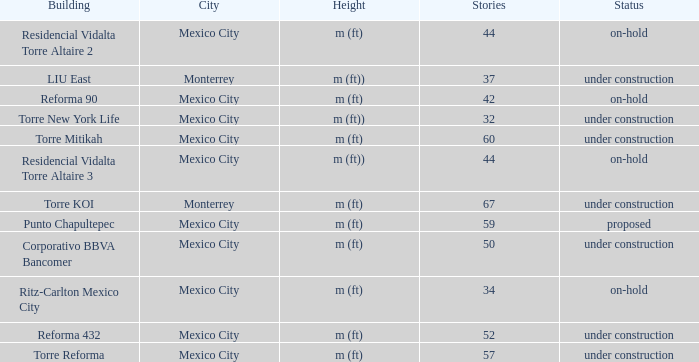How many stories is the torre reforma building? 1.0. 